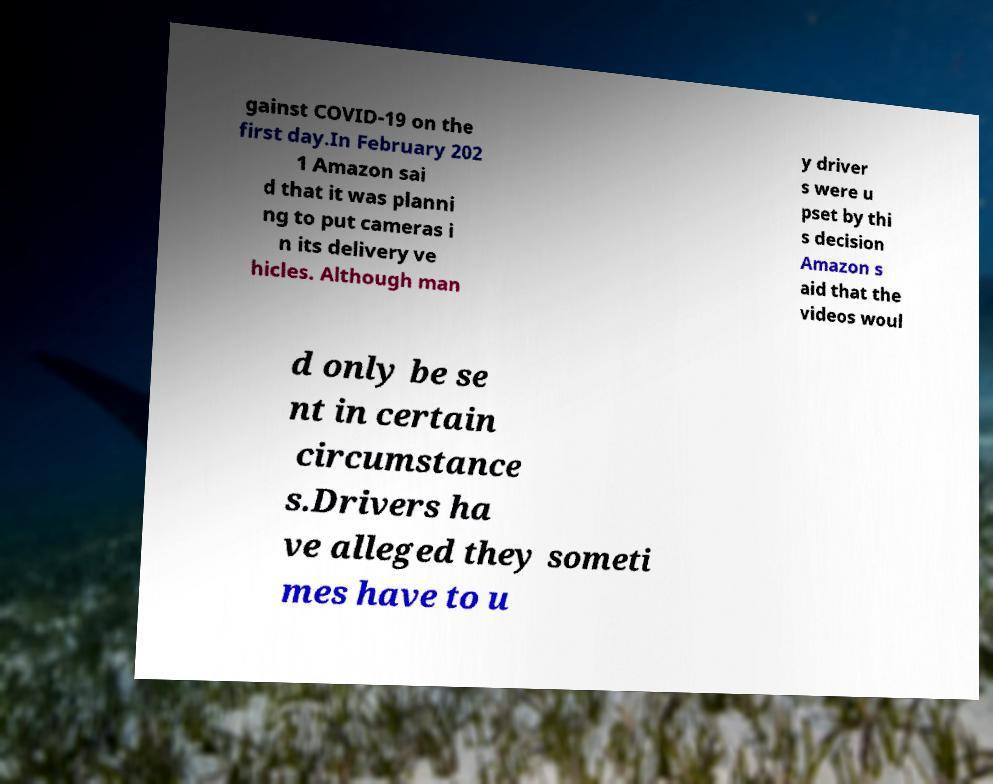Please identify and transcribe the text found in this image. gainst COVID-19 on the first day.In February 202 1 Amazon sai d that it was planni ng to put cameras i n its delivery ve hicles. Although man y driver s were u pset by thi s decision Amazon s aid that the videos woul d only be se nt in certain circumstance s.Drivers ha ve alleged they someti mes have to u 